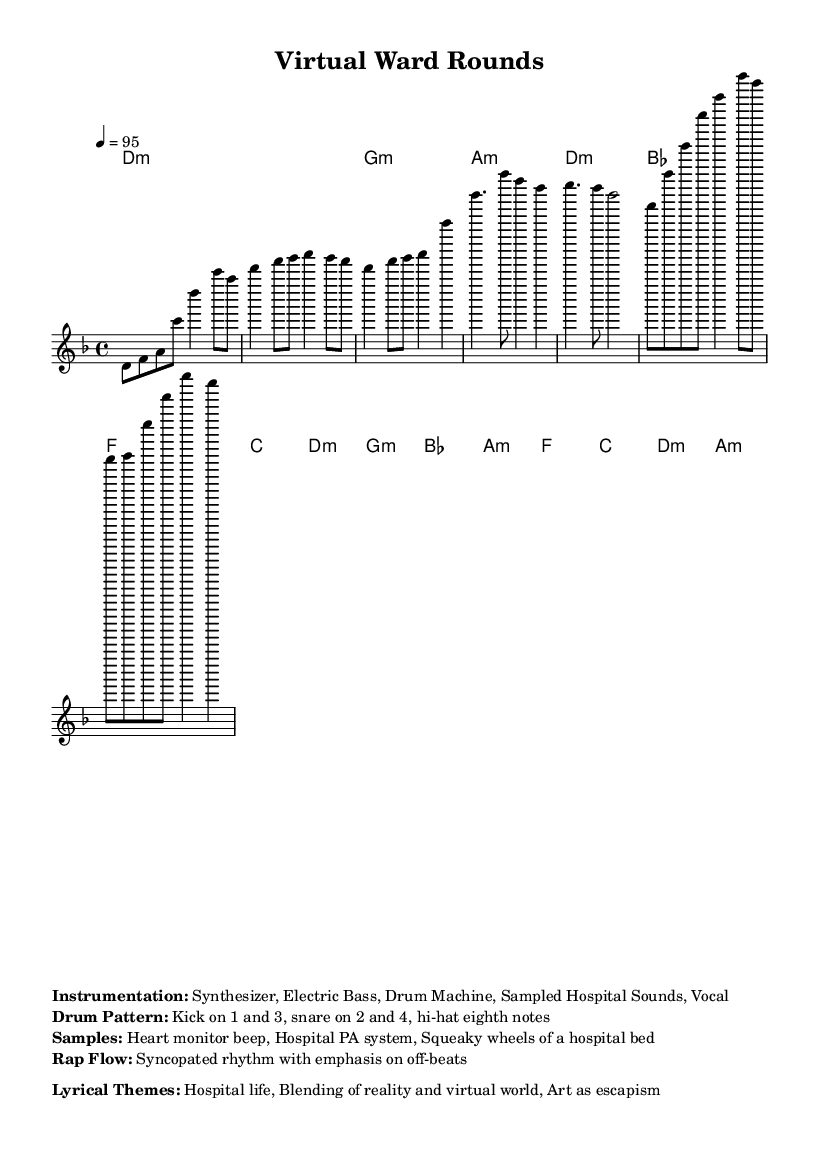What is the key signature of this music? The key signature is indicated at the beginning of the score, which shows D minor with one flat (B flat).
Answer: D minor What is the time signature of the piece? The time signature appears at the start of the score, displayed as 4/4, meaning four beats per measure.
Answer: 4/4 What is the tempo marking for this music? The tempo is specified in beats per minute (BPM), appearing next to the 'tempo' instruction as quarter note equals 95, indicating the speed.
Answer: 95 How many measures are there in the verse section? By counting the measures in the verse part of the melody, we find there are six measures in total.
Answer: 6 What type of instrumentation is used in this piece? The instrumentation is listed below the score, identifying the elements involved: Synthesizer, Electric Bass, Drum Machine, Sampled Hospital Sounds, Vocal.
Answer: Synthesizer, Electric Bass, Drum Machine, Sampled Hospital Sounds, Vocal What kind of samples are incorporated in this composition? The samples used are indicated in the markup section, highlighting hospital-related sounds that set the thematic focus, such as heart monitor beep and hospital PA system.
Answer: Heart monitor beep, Hospital PA system, Squeaky wheels of a hospital bed What lyrical theme is emphasized in this music piece? The thematic focus is identified in the markup, which describes the mood and concept: Hospital life and the blending of reality with a virtual world.
Answer: Hospital life, Blending of reality and virtual world, Art as escapism 